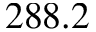<formula> <loc_0><loc_0><loc_500><loc_500>2 8 8 . 2</formula> 